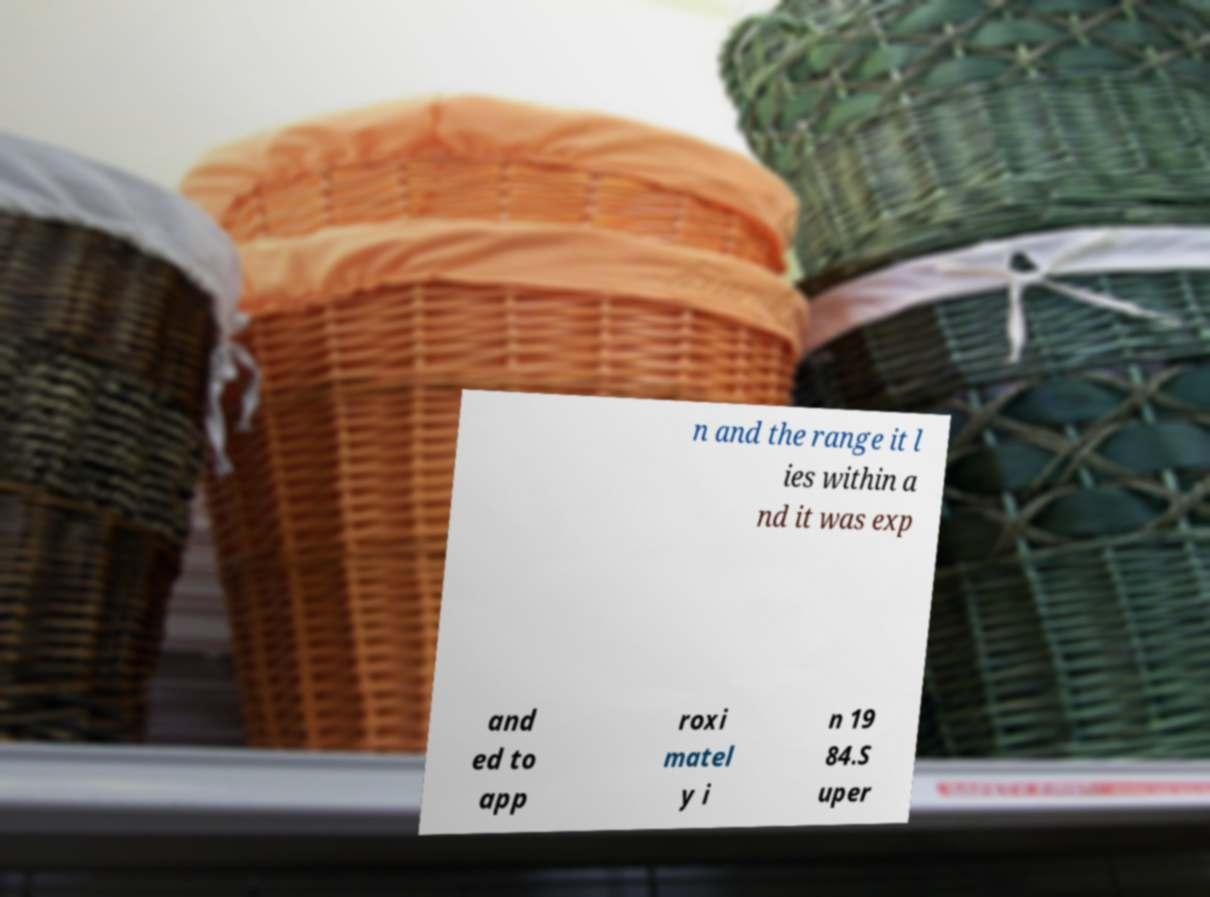Could you assist in decoding the text presented in this image and type it out clearly? n and the range it l ies within a nd it was exp and ed to app roxi matel y i n 19 84.S uper 